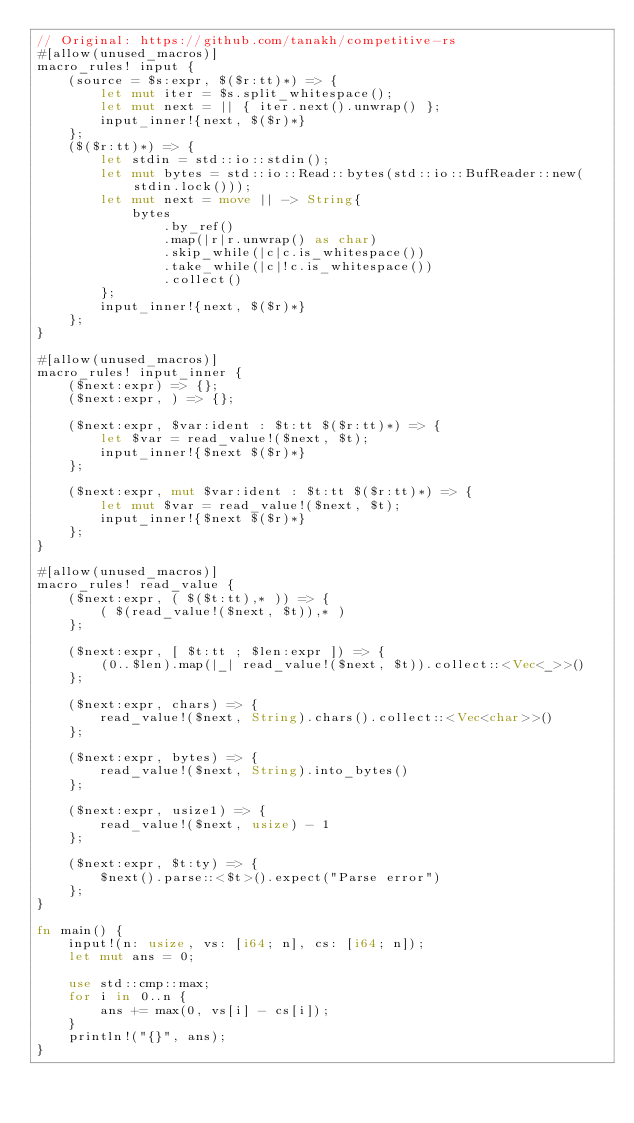<code> <loc_0><loc_0><loc_500><loc_500><_Rust_>// Original: https://github.com/tanakh/competitive-rs
#[allow(unused_macros)]
macro_rules! input {
    (source = $s:expr, $($r:tt)*) => {
        let mut iter = $s.split_whitespace();
        let mut next = || { iter.next().unwrap() };
        input_inner!{next, $($r)*}
    };
    ($($r:tt)*) => {
        let stdin = std::io::stdin();
        let mut bytes = std::io::Read::bytes(std::io::BufReader::new(stdin.lock()));
        let mut next = move || -> String{
            bytes
                .by_ref()
                .map(|r|r.unwrap() as char)
                .skip_while(|c|c.is_whitespace())
                .take_while(|c|!c.is_whitespace())
                .collect()
        };
        input_inner!{next, $($r)*}
    };
}

#[allow(unused_macros)]
macro_rules! input_inner {
    ($next:expr) => {};
    ($next:expr, ) => {};

    ($next:expr, $var:ident : $t:tt $($r:tt)*) => {
        let $var = read_value!($next, $t);
        input_inner!{$next $($r)*}
    };

    ($next:expr, mut $var:ident : $t:tt $($r:tt)*) => {
        let mut $var = read_value!($next, $t);
        input_inner!{$next $($r)*}
    };
}

#[allow(unused_macros)]
macro_rules! read_value {
    ($next:expr, ( $($t:tt),* )) => {
        ( $(read_value!($next, $t)),* )
    };

    ($next:expr, [ $t:tt ; $len:expr ]) => {
        (0..$len).map(|_| read_value!($next, $t)).collect::<Vec<_>>()
    };

    ($next:expr, chars) => {
        read_value!($next, String).chars().collect::<Vec<char>>()
    };

    ($next:expr, bytes) => {
        read_value!($next, String).into_bytes()
    };

    ($next:expr, usize1) => {
        read_value!($next, usize) - 1
    };

    ($next:expr, $t:ty) => {
        $next().parse::<$t>().expect("Parse error")
    };
}

fn main() {
    input!(n: usize, vs: [i64; n], cs: [i64; n]);
    let mut ans = 0;

    use std::cmp::max;
    for i in 0..n {
        ans += max(0, vs[i] - cs[i]);
    }
    println!("{}", ans);
}
</code> 